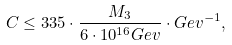<formula> <loc_0><loc_0><loc_500><loc_500>C \leq 3 3 5 \cdot \frac { M _ { 3 } } { 6 \cdot 1 0 ^ { 1 6 } G e v } \cdot { G e v } ^ { - 1 } ,</formula> 